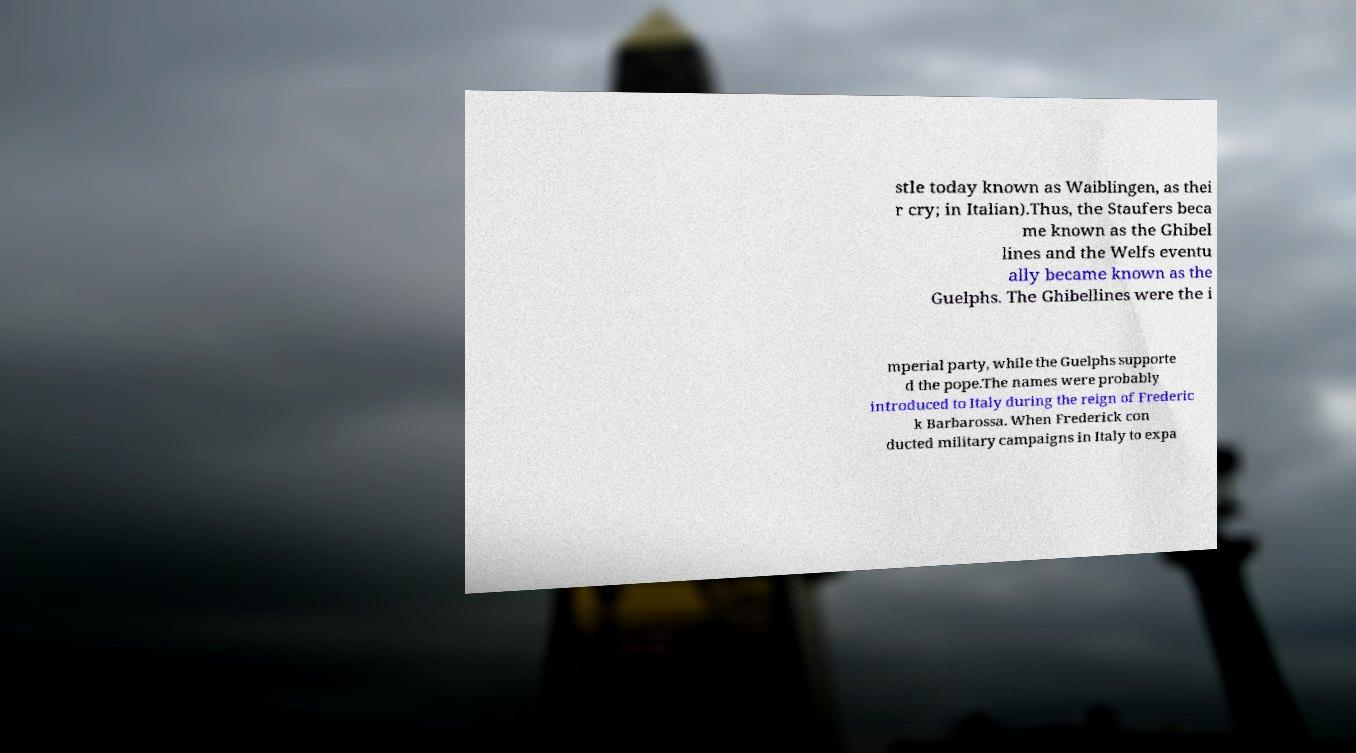I need the written content from this picture converted into text. Can you do that? stle today known as Waiblingen, as thei r cry; in Italian).Thus, the Staufers beca me known as the Ghibel lines and the Welfs eventu ally became known as the Guelphs. The Ghibellines were the i mperial party, while the Guelphs supporte d the pope.The names were probably introduced to Italy during the reign of Frederic k Barbarossa. When Frederick con ducted military campaigns in Italy to expa 